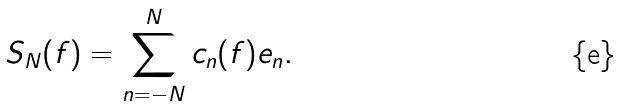Convert formula to latex. <formula><loc_0><loc_0><loc_500><loc_500>S _ { N } ( f ) = \sum _ { n = - N } ^ { N } c _ { n } ( f ) e _ { n } .</formula> 